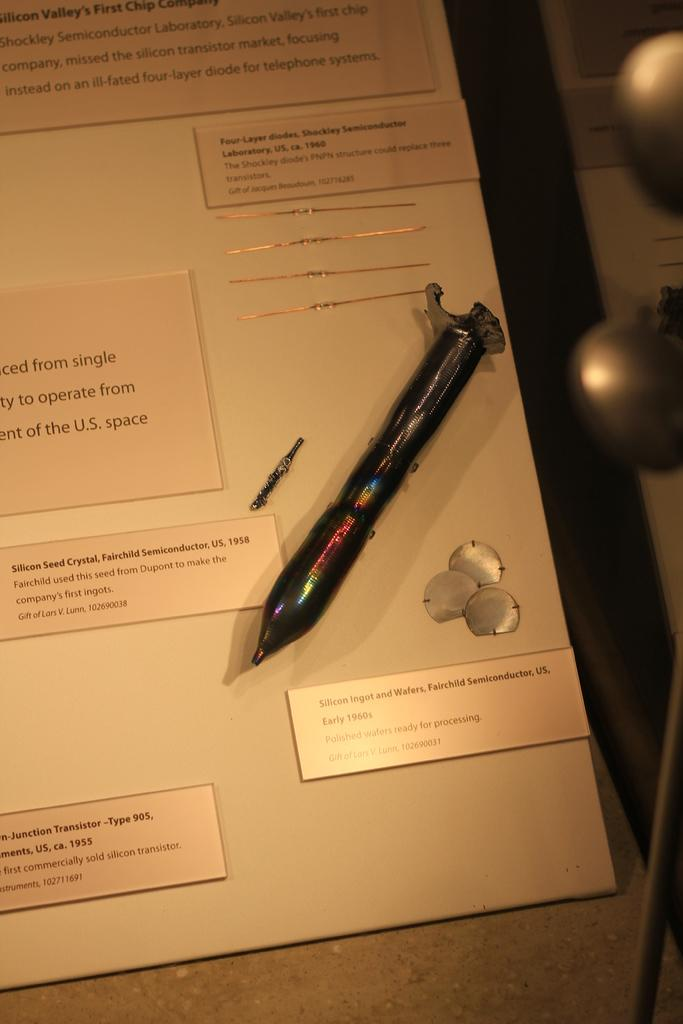What is the main object in the image? There is a board in the image. What is placed on the board? There is a pen on the board. What can be seen on the board besides the pen? There are labels with names on the board. How many spiders are crawling on the board in the image? There are no spiders present in the image. What type of camera is used to take the picture of the board? The type of camera used to take the picture is not mentioned in the image or the provided facts. 